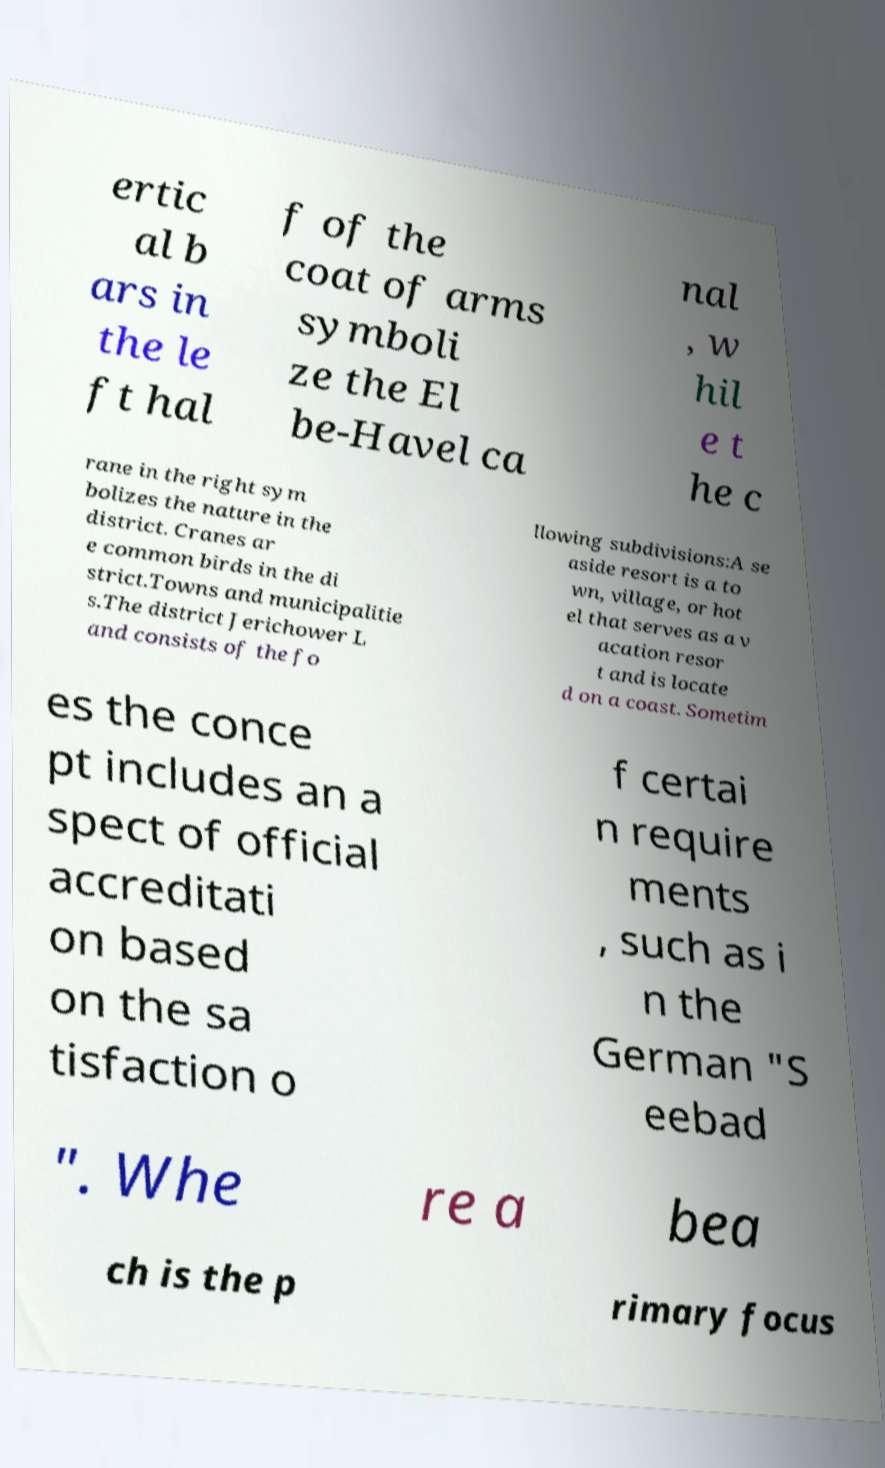Could you extract and type out the text from this image? ertic al b ars in the le ft hal f of the coat of arms symboli ze the El be-Havel ca nal , w hil e t he c rane in the right sym bolizes the nature in the district. Cranes ar e common birds in the di strict.Towns and municipalitie s.The district Jerichower L and consists of the fo llowing subdivisions:A se aside resort is a to wn, village, or hot el that serves as a v acation resor t and is locate d on a coast. Sometim es the conce pt includes an a spect of official accreditati on based on the sa tisfaction o f certai n require ments , such as i n the German "S eebad ". Whe re a bea ch is the p rimary focus 